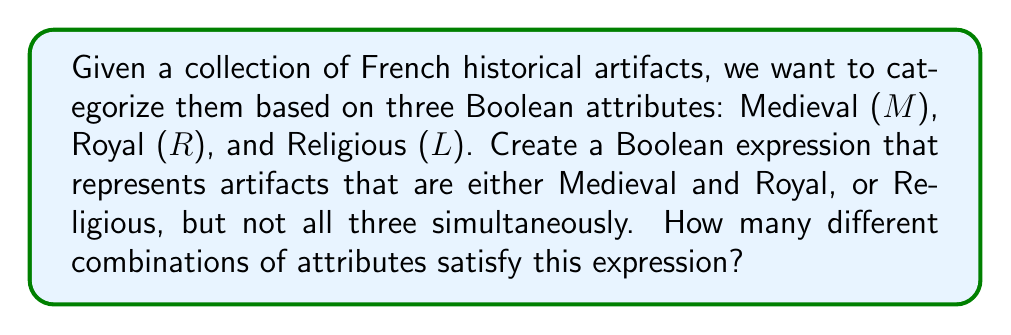Solve this math problem. Let's approach this step-by-step:

1) First, we need to translate the given conditions into a Boolean expression:
   (Medieval AND Royal) OR Religious, but not all three
   
   In Boolean algebra, this can be written as:
   $$(M \wedge R) \vee L \wedge \neg(M \wedge R \wedge L)$$

2) To simplify this, let's distribute the $\neg$ over $(M \wedge R \wedge L)$:
   $$(M \wedge R) \vee L \wedge (\neg M \vee \neg R \vee \neg L)$$

3) Now, we can use the distributive property:
   $$(M \wedge R \wedge \neg M) \vee (M \wedge R \wedge \neg R) \vee (M \wedge R \wedge \neg L) \vee (L \wedge \neg M) \vee (L \wedge \neg R) \vee (L \wedge \neg L)$$

4) Simplify:
   - $(M \wedge R \wedge \neg M)$ and $(M \wedge R \wedge \neg R)$ are always false
   - $(L \wedge \neg L)$ is always false
   - $(M \wedge R \wedge \neg L)$ represents Medieval AND Royal BUT NOT Religious
   - $(L \wedge \neg M)$ represents Religious BUT NOT Medieval
   - $(L \wedge \neg R)$ represents Religious BUT NOT Royal

5) So, our simplified expression represents three possible combinations:
   - Medieval AND Royal BUT NOT Religious
   - Religious BUT NOT Medieval (regardless of Royal)
   - Religious BUT NOT Royal (regardless of Medieval)

6) These three combinations are mutually exclusive and cover all possibilities that satisfy our original expression.

Therefore, there are 3 different combinations of attributes that satisfy this expression.
Answer: 3 